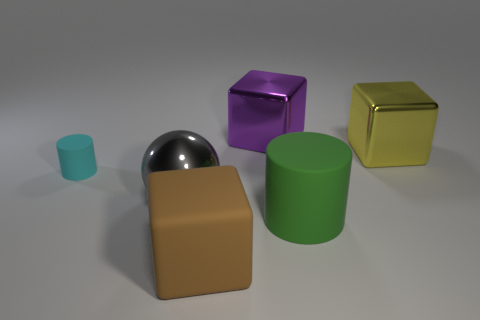Add 4 big brown matte cubes. How many objects exist? 10 Subtract all balls. How many objects are left? 5 Subtract all large metal things. Subtract all large yellow metal cylinders. How many objects are left? 3 Add 6 purple metal objects. How many purple metal objects are left? 7 Add 2 large rubber things. How many large rubber things exist? 4 Subtract 0 blue balls. How many objects are left? 6 